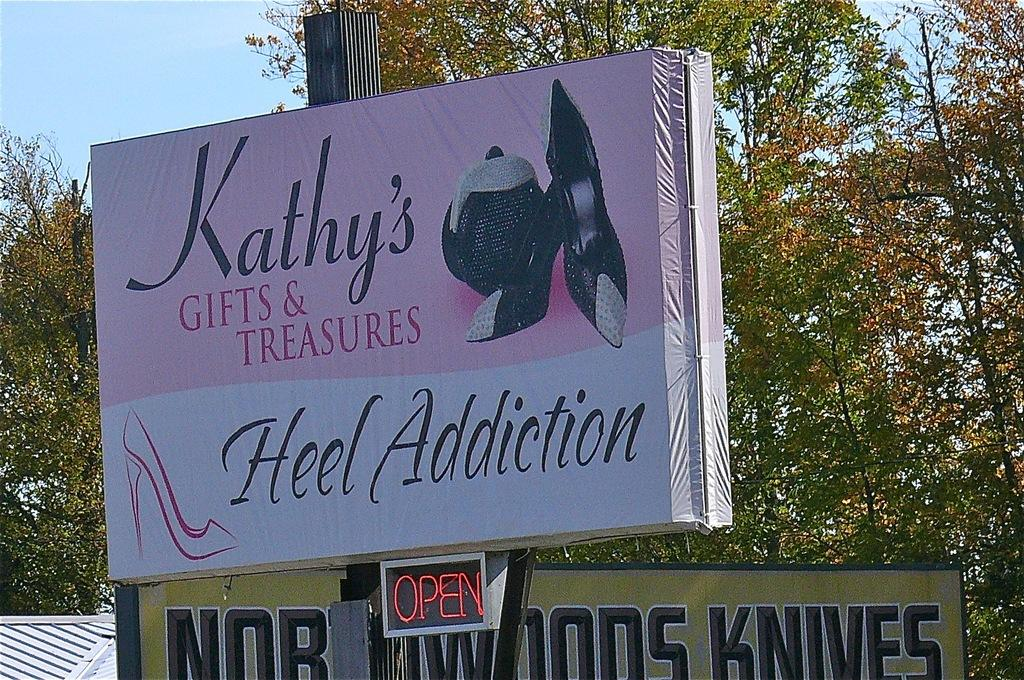<image>
Describe the image concisely. A white and pink sign says Kathy's Gifts & Treasures. 